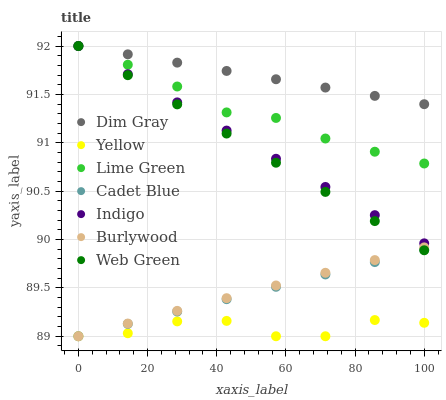Does Yellow have the minimum area under the curve?
Answer yes or no. Yes. Does Dim Gray have the maximum area under the curve?
Answer yes or no. Yes. Does Indigo have the minimum area under the curve?
Answer yes or no. No. Does Indigo have the maximum area under the curve?
Answer yes or no. No. Is Web Green the smoothest?
Answer yes or no. Yes. Is Yellow the roughest?
Answer yes or no. Yes. Is Indigo the smoothest?
Answer yes or no. No. Is Indigo the roughest?
Answer yes or no. No. Does Cadet Blue have the lowest value?
Answer yes or no. Yes. Does Indigo have the lowest value?
Answer yes or no. No. Does Lime Green have the highest value?
Answer yes or no. Yes. Does Burlywood have the highest value?
Answer yes or no. No. Is Cadet Blue less than Indigo?
Answer yes or no. Yes. Is Dim Gray greater than Yellow?
Answer yes or no. Yes. Does Burlywood intersect Web Green?
Answer yes or no. Yes. Is Burlywood less than Web Green?
Answer yes or no. No. Is Burlywood greater than Web Green?
Answer yes or no. No. Does Cadet Blue intersect Indigo?
Answer yes or no. No. 